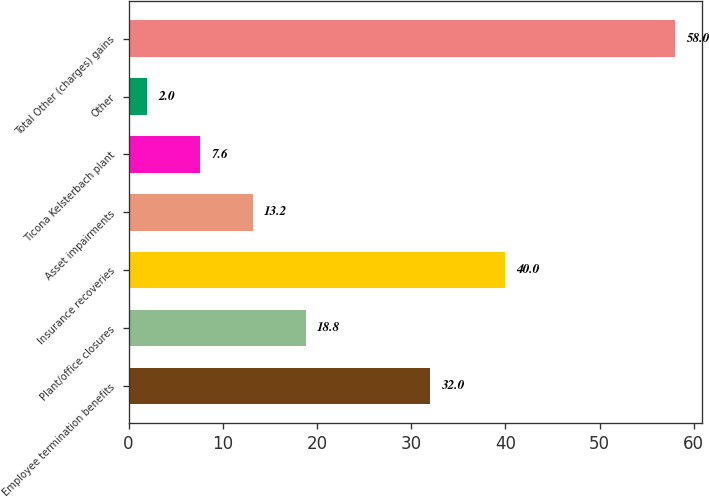Convert chart to OTSL. <chart><loc_0><loc_0><loc_500><loc_500><bar_chart><fcel>Employee termination benefits<fcel>Plant/office closures<fcel>Insurance recoveries<fcel>Asset impairments<fcel>Ticona Kelsterbach plant<fcel>Other<fcel>Total Other (charges) gains<nl><fcel>32<fcel>18.8<fcel>40<fcel>13.2<fcel>7.6<fcel>2<fcel>58<nl></chart> 